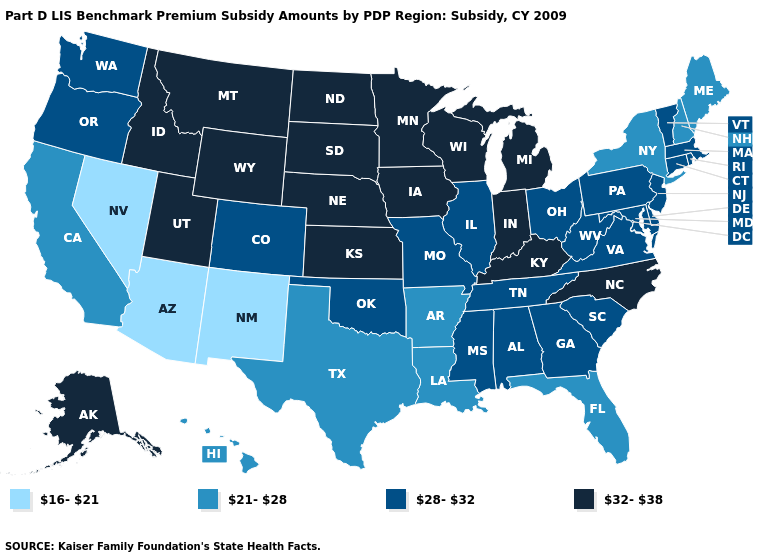Name the states that have a value in the range 32-38?
Be succinct. Alaska, Idaho, Indiana, Iowa, Kansas, Kentucky, Michigan, Minnesota, Montana, Nebraska, North Carolina, North Dakota, South Dakota, Utah, Wisconsin, Wyoming. What is the value of Alaska?
Be succinct. 32-38. Which states hav the highest value in the West?
Answer briefly. Alaska, Idaho, Montana, Utah, Wyoming. Does Kansas have the highest value in the USA?
Give a very brief answer. Yes. Among the states that border Idaho , which have the lowest value?
Be succinct. Nevada. Which states hav the highest value in the MidWest?
Keep it brief. Indiana, Iowa, Kansas, Michigan, Minnesota, Nebraska, North Dakota, South Dakota, Wisconsin. What is the value of Maine?
Write a very short answer. 21-28. Does Ohio have the lowest value in the MidWest?
Be succinct. Yes. Does South Dakota have a higher value than Virginia?
Short answer required. Yes. Among the states that border Nevada , which have the highest value?
Short answer required. Idaho, Utah. What is the value of South Carolina?
Write a very short answer. 28-32. Among the states that border Pennsylvania , which have the lowest value?
Quick response, please. New York. Name the states that have a value in the range 16-21?
Write a very short answer. Arizona, Nevada, New Mexico. Does Indiana have the lowest value in the MidWest?
Keep it brief. No. What is the lowest value in the USA?
Be succinct. 16-21. 